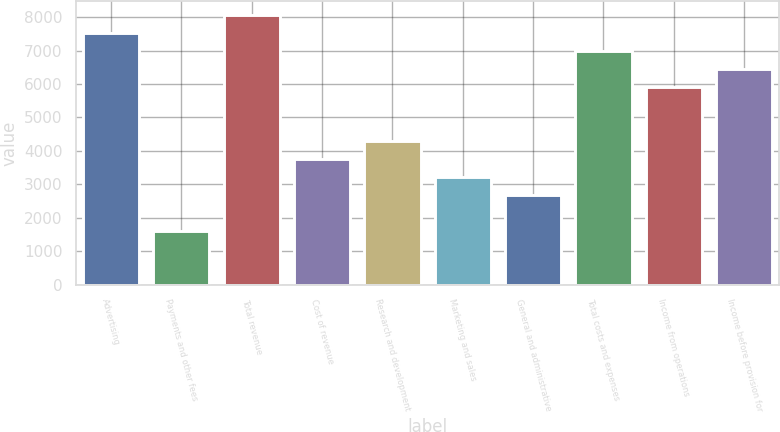<chart> <loc_0><loc_0><loc_500><loc_500><bar_chart><fcel>Advertising<fcel>Payments and other fees<fcel>Total revenue<fcel>Cost of revenue<fcel>Research and development<fcel>Marketing and sales<fcel>General and administrative<fcel>Total costs and expenses<fcel>Income from operations<fcel>Income before provision for<nl><fcel>7534.56<fcel>1615.02<fcel>8072.7<fcel>3767.58<fcel>4305.72<fcel>3229.44<fcel>2691.3<fcel>6996.42<fcel>5920.14<fcel>6458.28<nl></chart> 